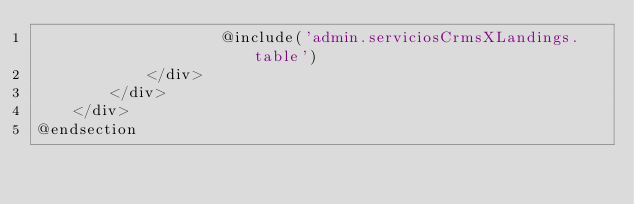<code> <loc_0><loc_0><loc_500><loc_500><_PHP_>                    @include('admin.serviciosCrmsXLandings.table')
            </div>
        </div>
    </div>
@endsection

</code> 